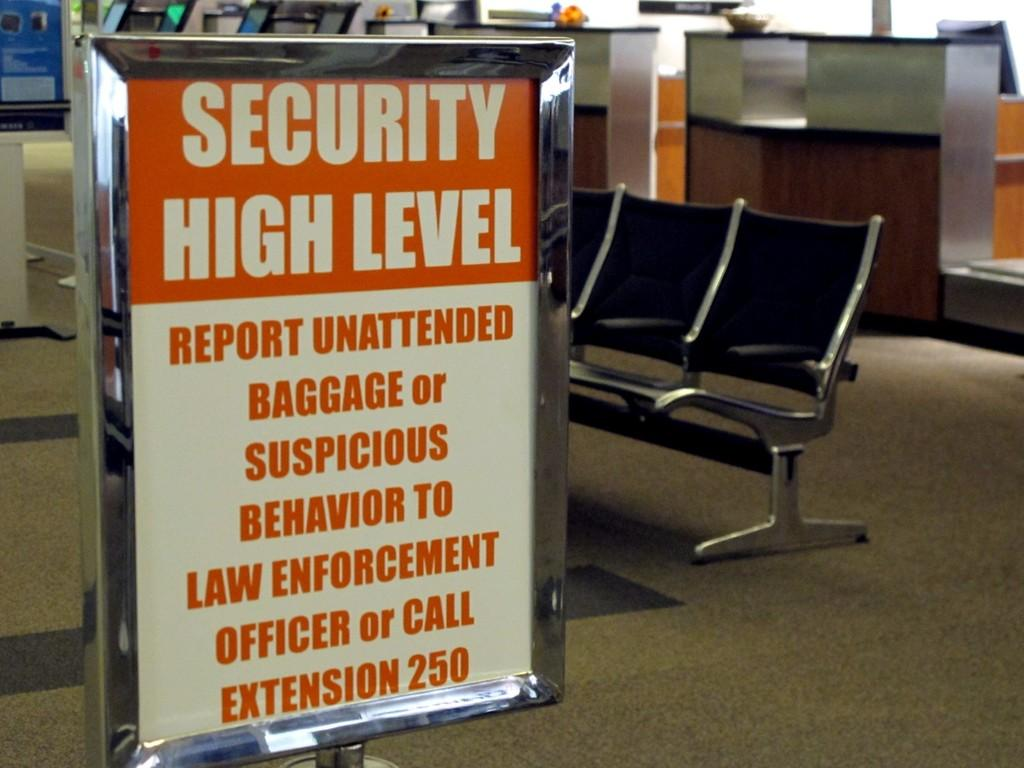Provide a one-sentence caption for the provided image. A red and white sign in an airport that says Security High Level. 